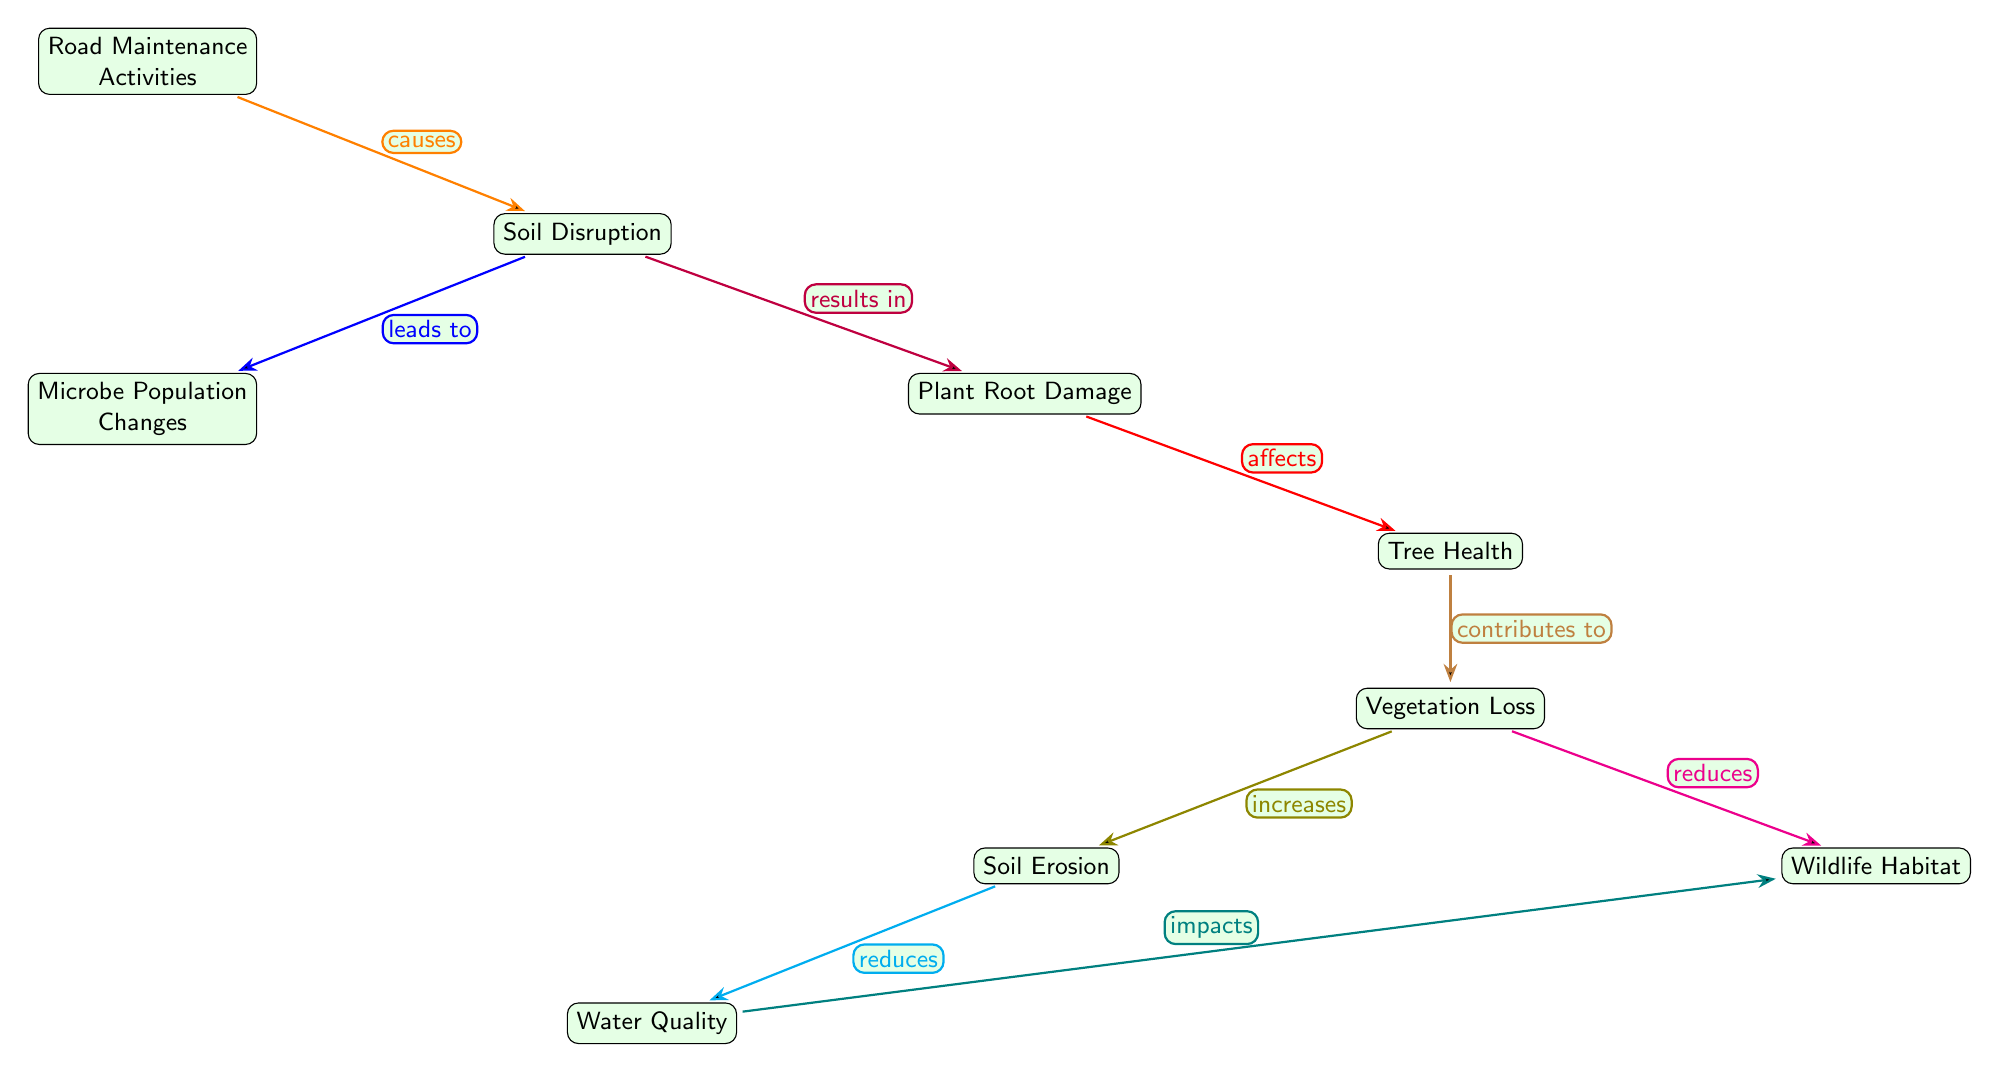What causes soil disruption? The diagram indicates that "Road Maintenance Activities" is the primary cause of "Soil Disruption."
Answer: Road Maintenance Activities How many nodes are present in the diagram? Counting the nodes listed, there are a total of 8 nodes in the diagram.
Answer: 8 What is the relationship between soil disruption and microbe population changes? The diagram shows a labeled edge from "Soil Disruption" to "Microbe Population Changes" stating that soil disruption "leads to" changes in microbe populations.
Answer: leads to What do plant root damages affect? According to the diagram, "Plant Root Damage" affects "Tree Health," meaning that damage to plant roots has a direct impact on the health of trees.
Answer: Tree Health What increase follows vegetation loss? "Vegetation Loss" increases "Soil Erosion," indicating that when vegetation is lost, soil erosion tends to increase as a consequence.
Answer: Soil Erosion What impacts wildlife according to the diagram? The diagram illustrates that "Water Quality" impacts "Wildlife Habitat," meaning that changes in water quality can have an effect on wildlife habitats.
Answer: impacts What is a result of tree health? The diagram indicates that "Tree Health" contributes to "Vegetation Loss," which means that tree health has a direct contribution to the overall amount of vegetation.
Answer: contributes to What occurs after soil erosion? The "Soil Erosion" results in a reduction of "Water Quality," showing a direct consequence where increased erosion leads to poorer water quality.
Answer: reduces 